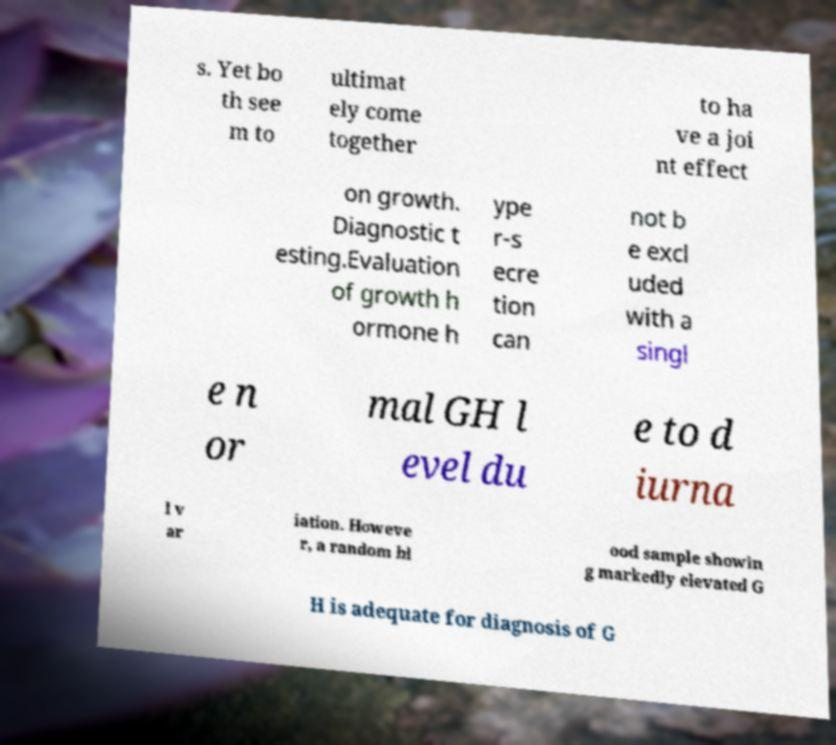What messages or text are displayed in this image? I need them in a readable, typed format. s. Yet bo th see m to ultimat ely come together to ha ve a joi nt effect on growth. Diagnostic t esting.Evaluation of growth h ormone h ype r-s ecre tion can not b e excl uded with a singl e n or mal GH l evel du e to d iurna l v ar iation. Howeve r, a random bl ood sample showin g markedly elevated G H is adequate for diagnosis of G 